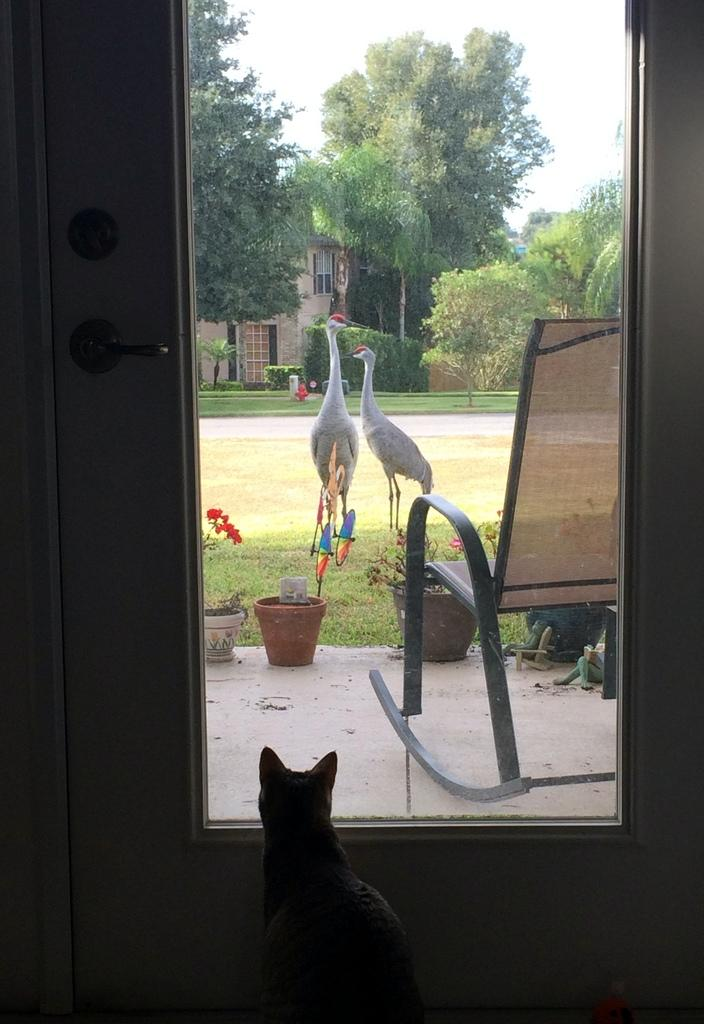How many birds are in the image? There are two birds in the image. What other objects or animals can be seen in the image? There is a chair, a cat, trees, and a building in the image. What type of government is depicted in the image? There is no depiction of a government in the image; it features two birds, a chair, a cat, trees, and a building. How many planes can be seen flying in the image? There are no planes visible in the image. 